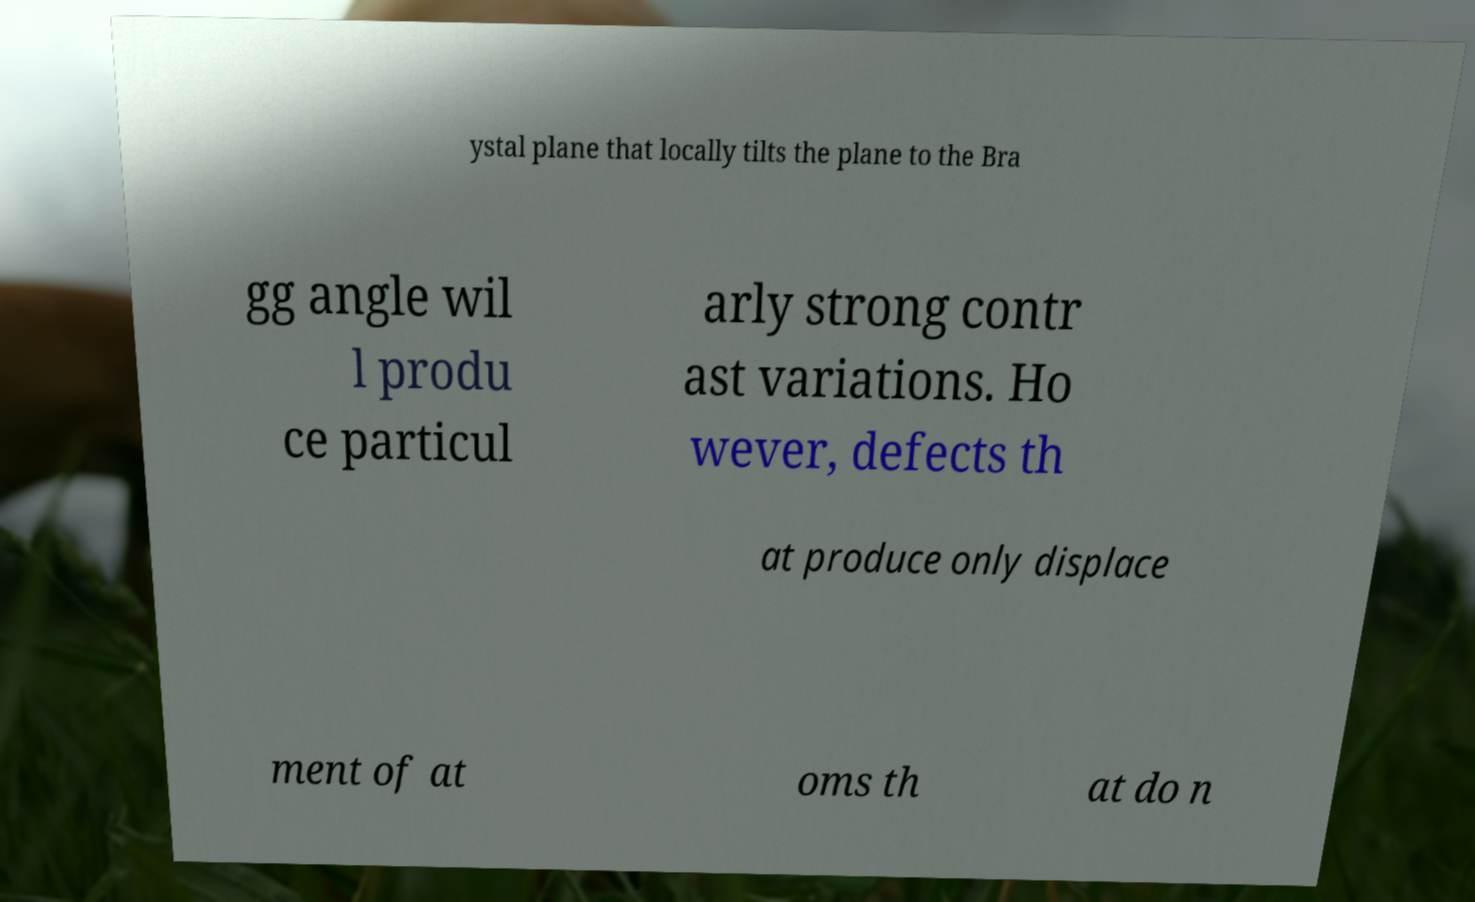Could you assist in decoding the text presented in this image and type it out clearly? ystal plane that locally tilts the plane to the Bra gg angle wil l produ ce particul arly strong contr ast variations. Ho wever, defects th at produce only displace ment of at oms th at do n 